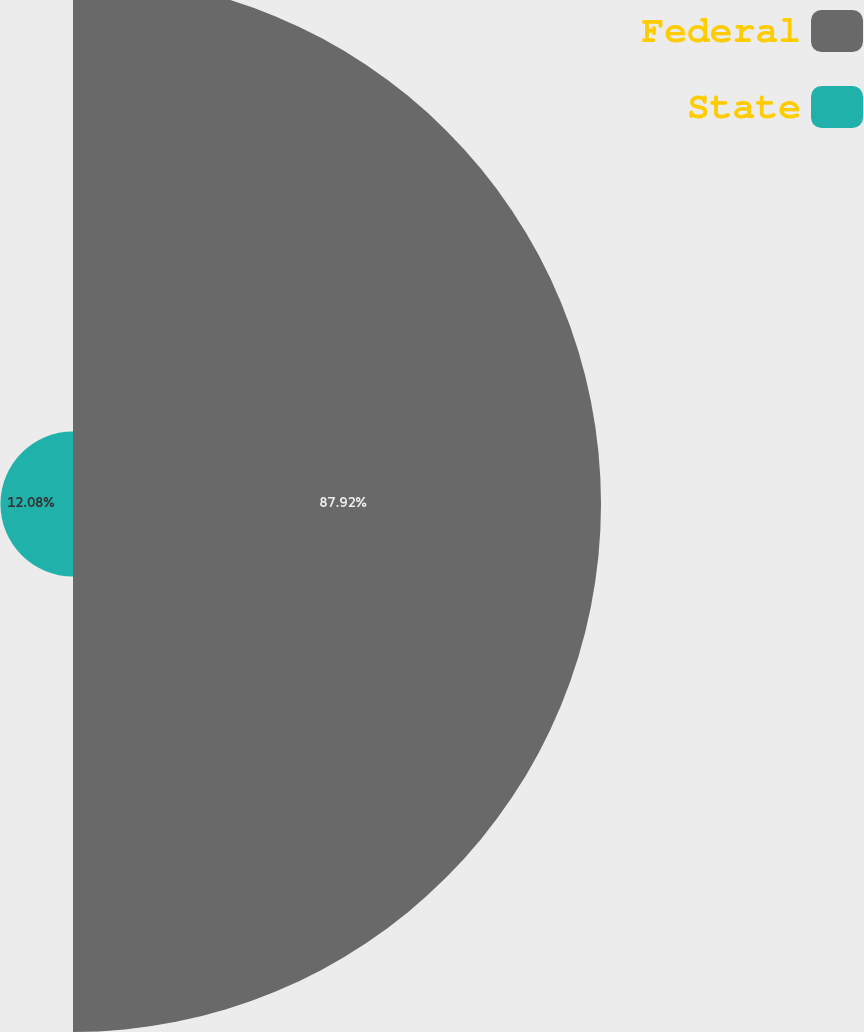<chart> <loc_0><loc_0><loc_500><loc_500><pie_chart><fcel>Federal<fcel>State<nl><fcel>87.92%<fcel>12.08%<nl></chart> 